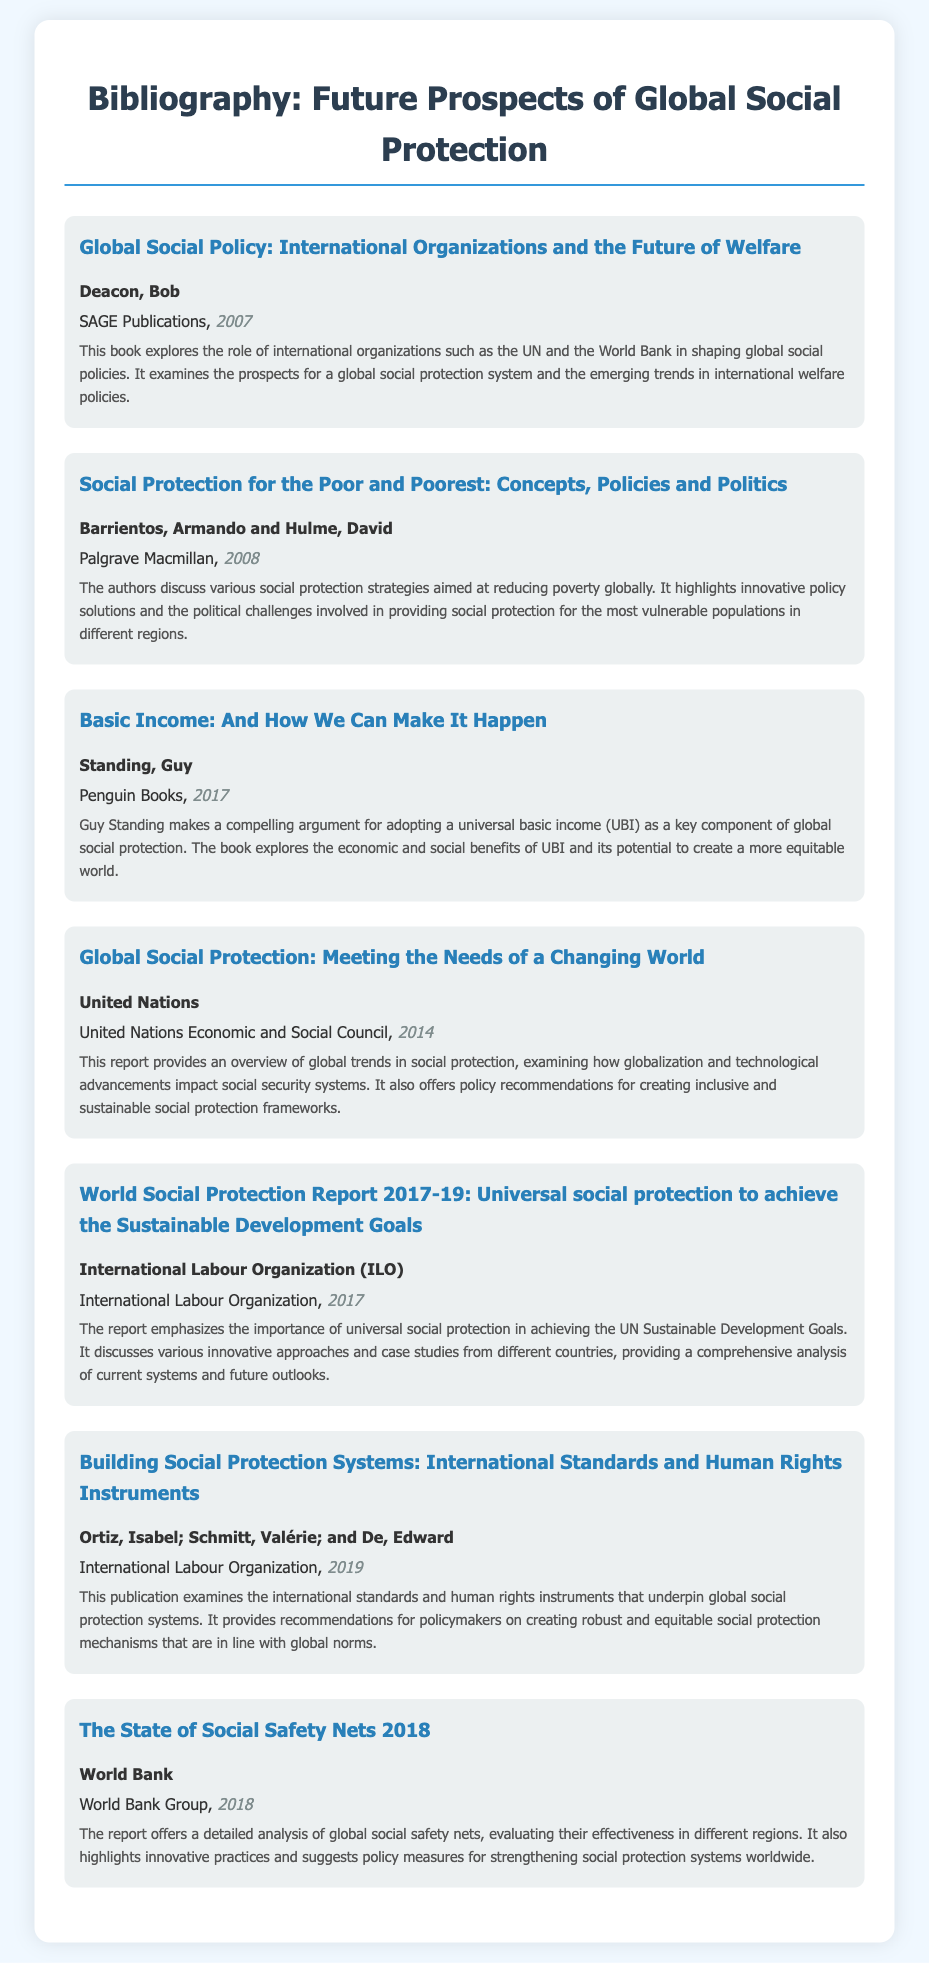What is the title of the first entry? The title can be found in the first entry of the bibliography, which is explicitly stated.
Answer: Global Social Policy: International Organizations and the Future of Welfare Who is the author of the book "Basic Income: And How We Can Make It Happen"? The author of this book is mentioned directly in the entry.
Answer: Standing, Guy What year was "Social Protection for the Poor and Poorest" published? The publication year is indicated in the entry for this book.
Answer: 2008 Which organization published the "World Social Protection Report 2017-19"? The publisher is clearly listed in the entry related to this report.
Answer: International Labour Organization (ILO) What is the main focus of the publication by the United Nations from 2014? The summary of the entry provides insight into the core topic of the publication.
Answer: Overview of global trends in social protection What innovative approach is emphasized in the "World Social Protection Report 2017-19"? The key focus of the report can be derived from its summary, highlighting an important aspect.
Answer: Universal social protection How many entries in total are there in this bibliography? The total number of entries is the count of distinct publication items listed in the document.
Answer: 7 Which publication discusses the international standards for social protection systems? The title of the entry related to international standards will directly answer this question.
Answer: Building Social Protection Systems: International Standards and Human Rights Instruments What is the publication year for the report titled "The State of Social Safety Nets 2018"? The year is specified in the entry for this report.
Answer: 2018 